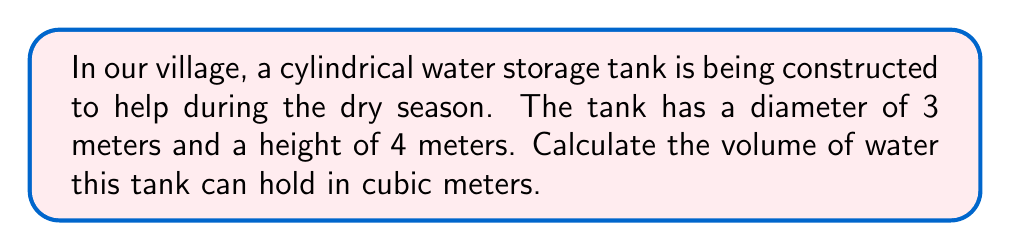Provide a solution to this math problem. Let's solve this step-by-step:

1) The formula for the volume of a cylinder is:
   $$V = \pi r^2 h$$
   where $V$ is volume, $r$ is radius, and $h$ is height.

2) We're given the diameter (3 meters) and height (4 meters).
   To find the radius, we divide the diameter by 2:
   $$r = \frac{3}{2} = 1.5 \text{ meters}$$

3) Now we can substitute our values into the formula:
   $$V = \pi (1.5\text{ m})^2 (4\text{ m})$$

4) Let's calculate:
   $$V = \pi (2.25\text{ m}^2) (4\text{ m})$$
   $$V = 9\pi \text{ m}^3$$

5) Using 3.14159 as an approximation for $\pi$:
   $$V \approx 9 \times 3.14159 \text{ m}^3 = 28.27431 \text{ m}^3$$

6) Rounding to two decimal places:
   $$V \approx 28.27 \text{ m}^3$$

[asy]
import geometry;

size(200);
real r = 30;
real h = 40;

path base = circle((0,0), r);
path top = circle((0,h), r);

draw(base);
draw(top);
draw((r,0)--(r,h));
draw((-r,0)--(-r,h));

label("3 m", (r,h/2), E);
label("4 m", (r+5,h/2), right);

draw((0,0)--(r,0), arrow=Arrow(TeXHead));
draw((0,h)--(r,h), arrow=Arrow(TeXHead));
[/asy]
Answer: $28.27 \text{ m}^3$ 